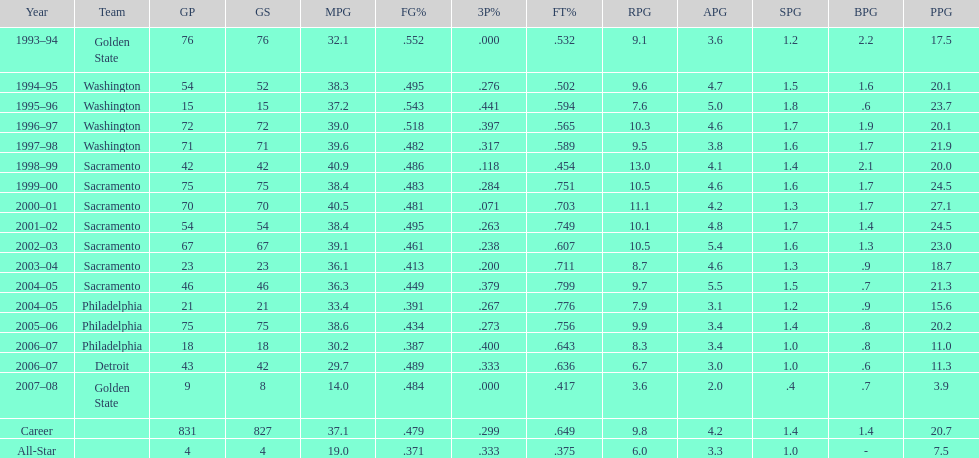How many seasons featured webber averaging more than 20 points per game (ppg)? 11. 